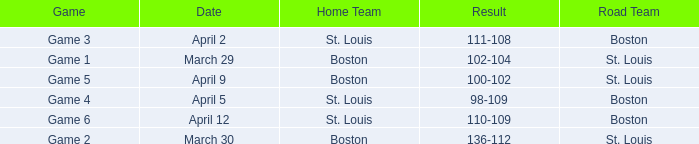What Game had a Result of 136-112? Game 2. 